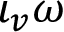Convert formula to latex. <formula><loc_0><loc_0><loc_500><loc_500>\iota _ { v } \omega</formula> 